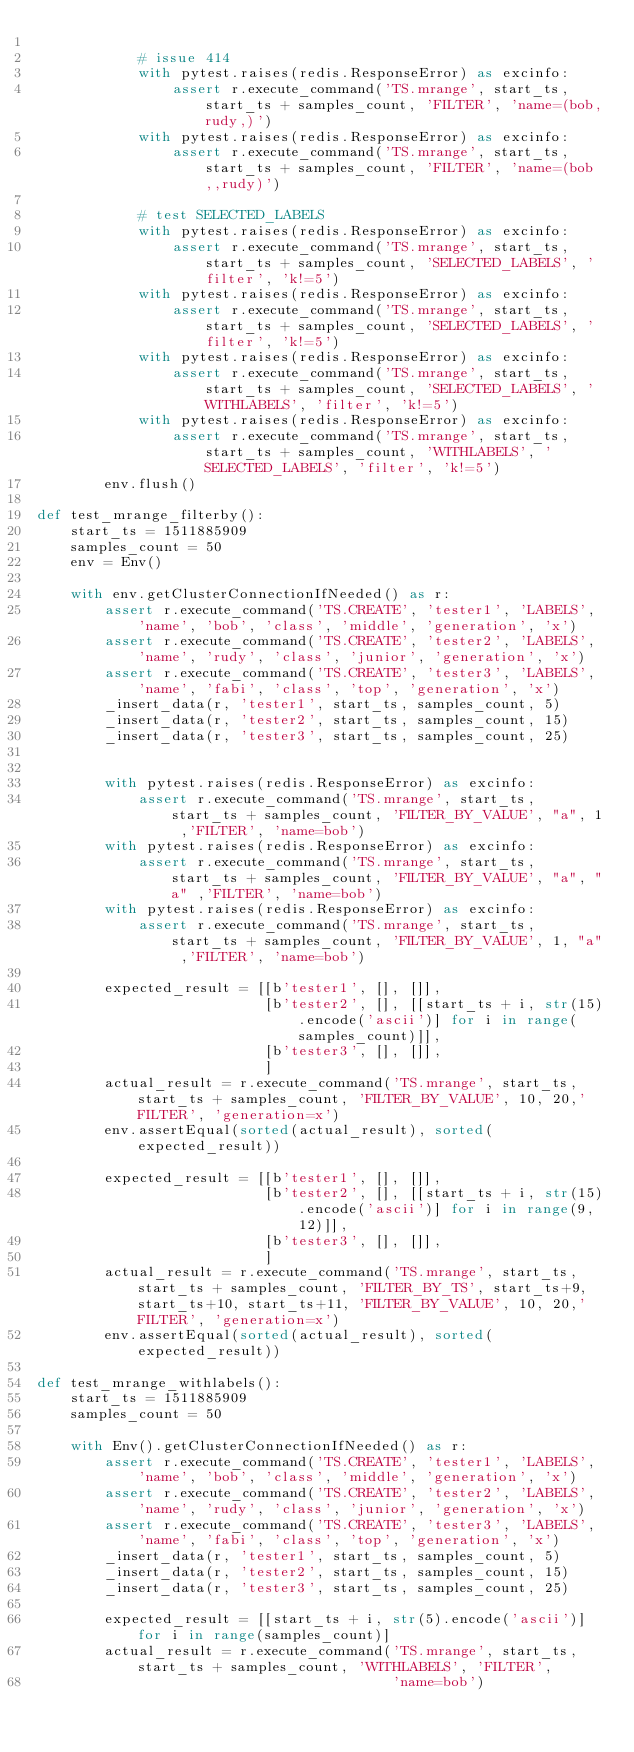<code> <loc_0><loc_0><loc_500><loc_500><_Python_>
            # issue 414
            with pytest.raises(redis.ResponseError) as excinfo:
                assert r.execute_command('TS.mrange', start_ts, start_ts + samples_count, 'FILTER', 'name=(bob,rudy,)')
            with pytest.raises(redis.ResponseError) as excinfo:
                assert r.execute_command('TS.mrange', start_ts, start_ts + samples_count, 'FILTER', 'name=(bob,,rudy)')

            # test SELECTED_LABELS
            with pytest.raises(redis.ResponseError) as excinfo:
                assert r.execute_command('TS.mrange', start_ts, start_ts + samples_count, 'SELECTED_LABELS', 'filter', 'k!=5')
            with pytest.raises(redis.ResponseError) as excinfo:
                assert r.execute_command('TS.mrange', start_ts, start_ts + samples_count, 'SELECTED_LABELS', 'filter', 'k!=5')
            with pytest.raises(redis.ResponseError) as excinfo:
                assert r.execute_command('TS.mrange', start_ts, start_ts + samples_count, 'SELECTED_LABELS', 'WITHLABELS', 'filter', 'k!=5')
            with pytest.raises(redis.ResponseError) as excinfo:
                assert r.execute_command('TS.mrange', start_ts, start_ts + samples_count, 'WITHLABELS', 'SELECTED_LABELS', 'filter', 'k!=5')
        env.flush()

def test_mrange_filterby():
    start_ts = 1511885909
    samples_count = 50
    env = Env()

    with env.getClusterConnectionIfNeeded() as r:
        assert r.execute_command('TS.CREATE', 'tester1', 'LABELS', 'name', 'bob', 'class', 'middle', 'generation', 'x')
        assert r.execute_command('TS.CREATE', 'tester2', 'LABELS', 'name', 'rudy', 'class', 'junior', 'generation', 'x')
        assert r.execute_command('TS.CREATE', 'tester3', 'LABELS', 'name', 'fabi', 'class', 'top', 'generation', 'x')
        _insert_data(r, 'tester1', start_ts, samples_count, 5)
        _insert_data(r, 'tester2', start_ts, samples_count, 15)
        _insert_data(r, 'tester3', start_ts, samples_count, 25)


        with pytest.raises(redis.ResponseError) as excinfo:
            assert r.execute_command('TS.mrange', start_ts, start_ts + samples_count, 'FILTER_BY_VALUE', "a", 1 ,'FILTER', 'name=bob')
        with pytest.raises(redis.ResponseError) as excinfo:
            assert r.execute_command('TS.mrange', start_ts, start_ts + samples_count, 'FILTER_BY_VALUE', "a", "a" ,'FILTER', 'name=bob')
        with pytest.raises(redis.ResponseError) as excinfo:
            assert r.execute_command('TS.mrange', start_ts, start_ts + samples_count, 'FILTER_BY_VALUE', 1, "a" ,'FILTER', 'name=bob')

        expected_result = [[b'tester1', [], []],
                           [b'tester2', [], [[start_ts + i, str(15).encode('ascii')] for i in range(samples_count)]],
                           [b'tester3', [], []],
                           ]
        actual_result = r.execute_command('TS.mrange', start_ts, start_ts + samples_count, 'FILTER_BY_VALUE', 10, 20,'FILTER', 'generation=x')
        env.assertEqual(sorted(actual_result), sorted(expected_result))

        expected_result = [[b'tester1', [], []],
                           [b'tester2', [], [[start_ts + i, str(15).encode('ascii')] for i in range(9, 12)]],
                           [b'tester3', [], []],
                           ]
        actual_result = r.execute_command('TS.mrange', start_ts, start_ts + samples_count, 'FILTER_BY_TS', start_ts+9, start_ts+10, start_ts+11, 'FILTER_BY_VALUE', 10, 20,'FILTER', 'generation=x')
        env.assertEqual(sorted(actual_result), sorted(expected_result))

def test_mrange_withlabels():
    start_ts = 1511885909
    samples_count = 50

    with Env().getClusterConnectionIfNeeded() as r:
        assert r.execute_command('TS.CREATE', 'tester1', 'LABELS', 'name', 'bob', 'class', 'middle', 'generation', 'x')
        assert r.execute_command('TS.CREATE', 'tester2', 'LABELS', 'name', 'rudy', 'class', 'junior', 'generation', 'x')
        assert r.execute_command('TS.CREATE', 'tester3', 'LABELS', 'name', 'fabi', 'class', 'top', 'generation', 'x')
        _insert_data(r, 'tester1', start_ts, samples_count, 5)
        _insert_data(r, 'tester2', start_ts, samples_count, 15)
        _insert_data(r, 'tester3', start_ts, samples_count, 25)

        expected_result = [[start_ts + i, str(5).encode('ascii')] for i in range(samples_count)]
        actual_result = r.execute_command('TS.mrange', start_ts, start_ts + samples_count, 'WITHLABELS', 'FILTER',
                                          'name=bob')</code> 